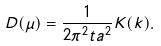Convert formula to latex. <formula><loc_0><loc_0><loc_500><loc_500>D ( \mu ) = \frac { 1 } { 2 \pi ^ { 2 } t a ^ { 2 } } K ( k ) .</formula> 